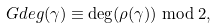<formula> <loc_0><loc_0><loc_500><loc_500>\ G d e g ( \gamma ) \equiv \deg ( \rho ( \gamma ) ) \bmod 2 ,</formula> 